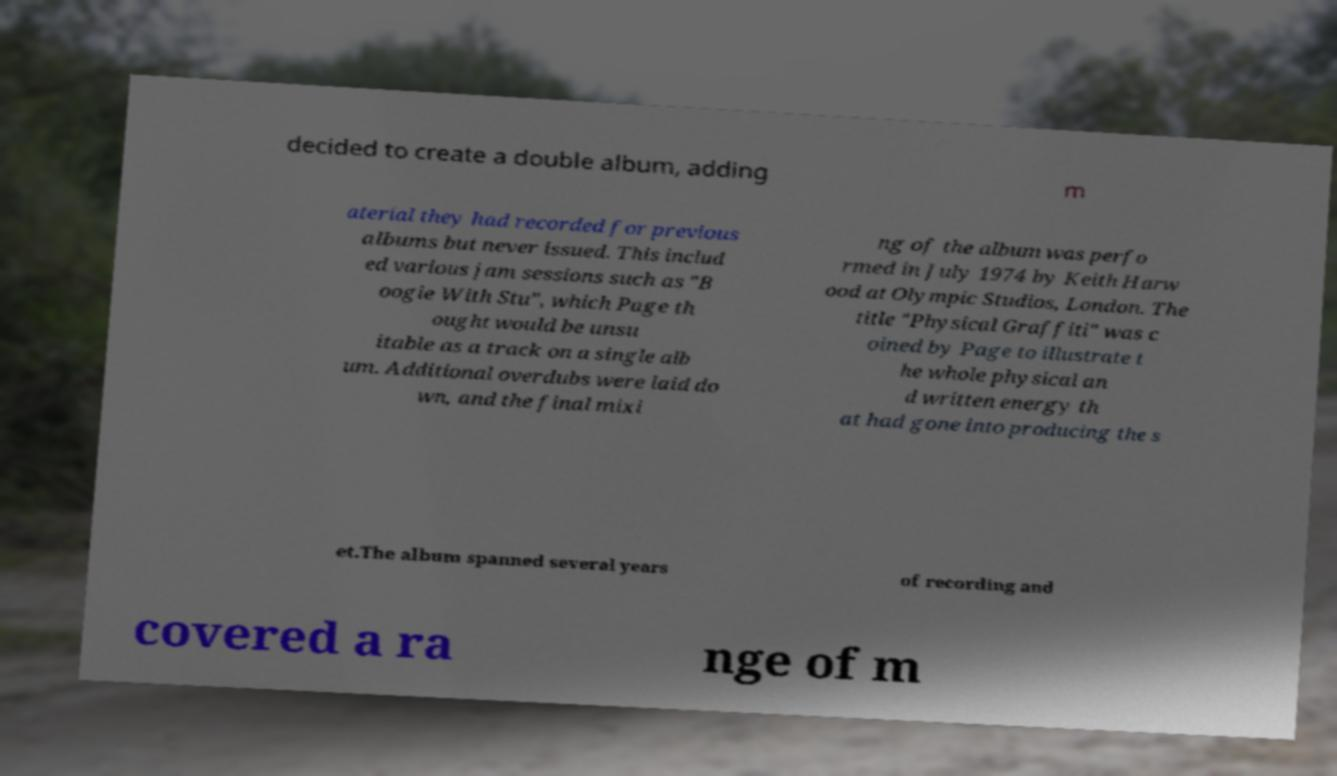For documentation purposes, I need the text within this image transcribed. Could you provide that? decided to create a double album, adding m aterial they had recorded for previous albums but never issued. This includ ed various jam sessions such as "B oogie With Stu", which Page th ought would be unsu itable as a track on a single alb um. Additional overdubs were laid do wn, and the final mixi ng of the album was perfo rmed in July 1974 by Keith Harw ood at Olympic Studios, London. The title "Physical Graffiti" was c oined by Page to illustrate t he whole physical an d written energy th at had gone into producing the s et.The album spanned several years of recording and covered a ra nge of m 